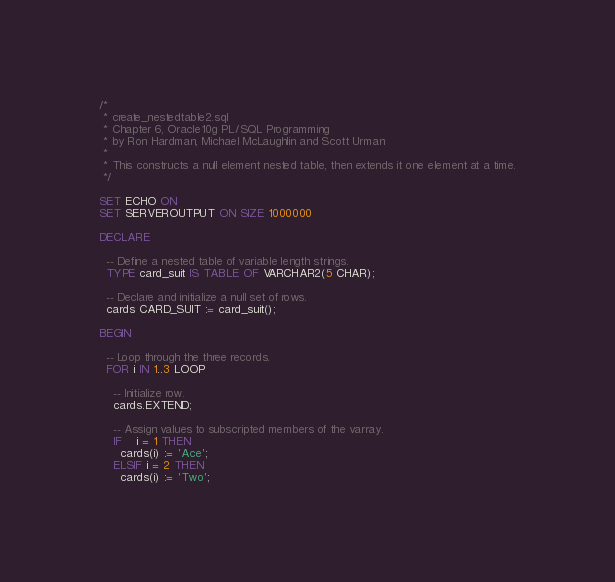Convert code to text. <code><loc_0><loc_0><loc_500><loc_500><_SQL_>/*
 * create_nestedtable2.sql
 * Chapter 6, Oracle10g PL/SQL Programming
 * by Ron Hardman, Michael McLaughlin and Scott Urman
 *
 * This constructs a null element nested table, then extends it one element at a time.
 */

SET ECHO ON
SET SERVEROUTPUT ON SIZE 1000000

DECLARE

  -- Define a nested table of variable length strings.
  TYPE card_suit IS TABLE OF VARCHAR2(5 CHAR);

  -- Declare and initialize a null set of rows.
  cards CARD_SUIT := card_suit();

BEGIN

  -- Loop through the three records.
  FOR i IN 1..3 LOOP

    -- Initialize row.
    cards.EXTEND;

    -- Assign values to subscripted members of the varray.
    IF    i = 1 THEN
      cards(i) := 'Ace';
    ELSIF i = 2 THEN
      cards(i) := 'Two';</code> 